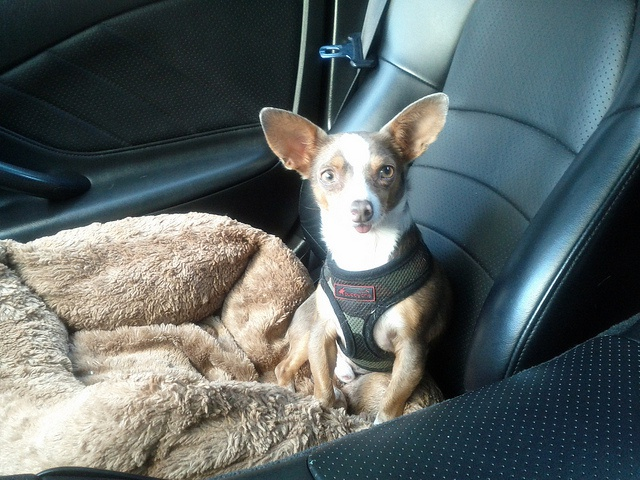Describe the objects in this image and their specific colors. I can see a dog in black, white, gray, and darkgray tones in this image. 